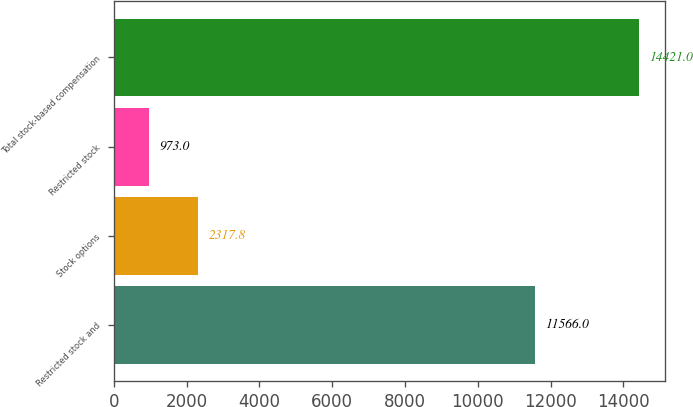Convert chart to OTSL. <chart><loc_0><loc_0><loc_500><loc_500><bar_chart><fcel>Restricted stock and<fcel>Stock options<fcel>Restricted stock<fcel>Total stock-based compensation<nl><fcel>11566<fcel>2317.8<fcel>973<fcel>14421<nl></chart> 